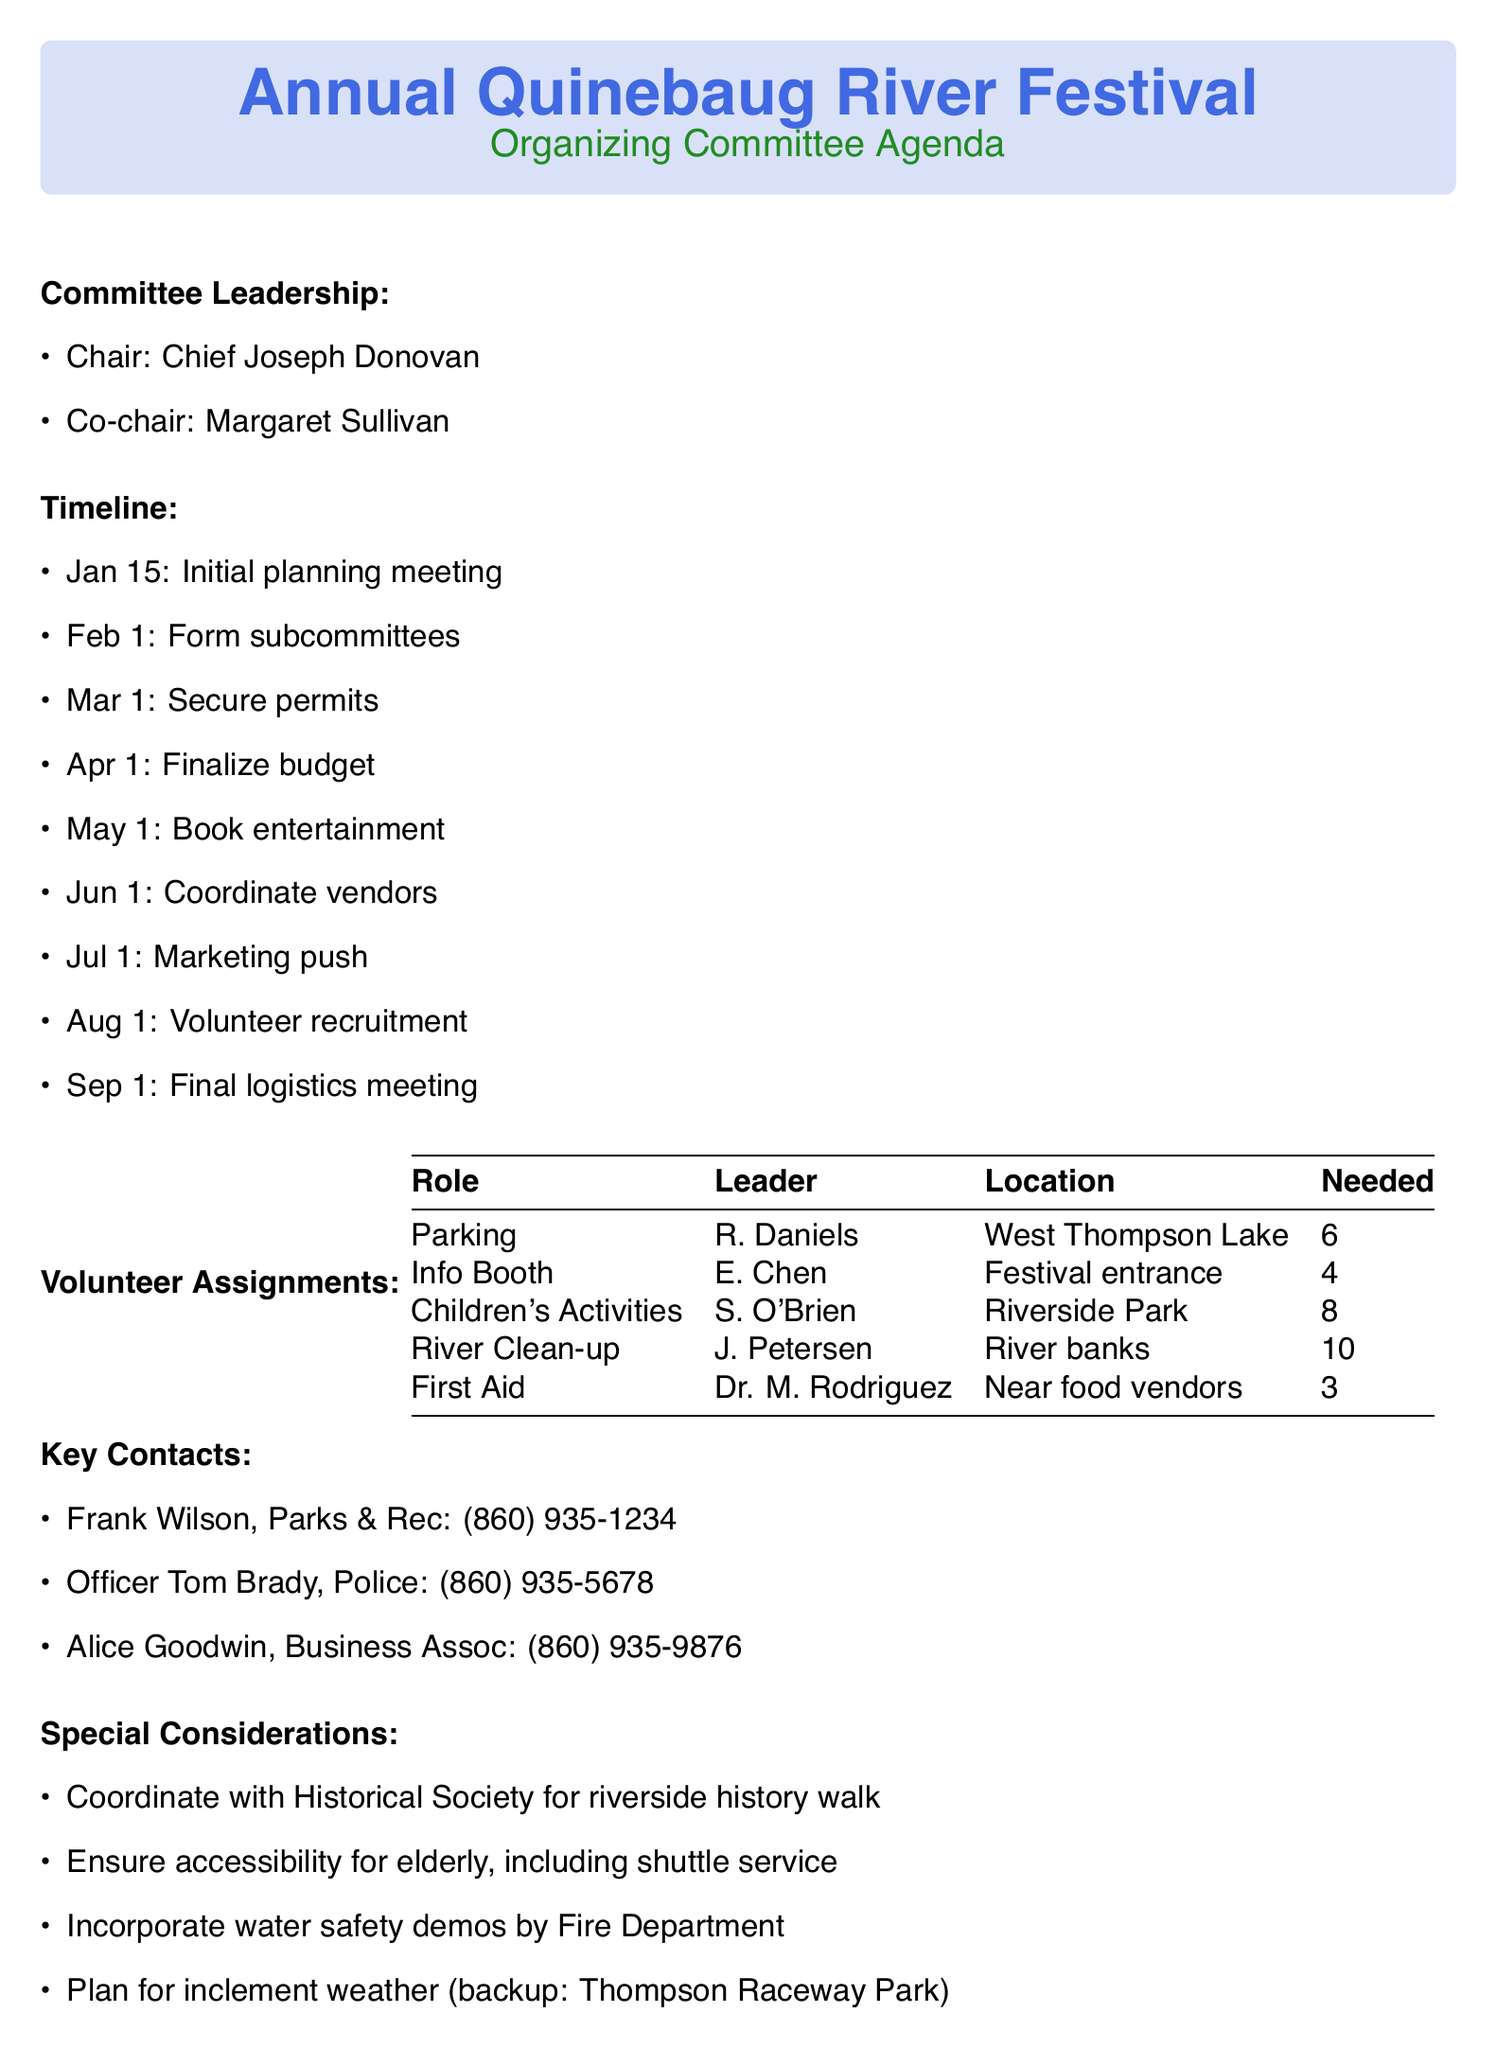What is the festival name? The festival name is explicitly stated in the document's header.
Answer: Annual Quinebaug River Festival Who is the chair of the organizing committee? The chair is mentioned in the committee leadership section of the document.
Answer: Chief Joseph Donovan When is the initial planning meeting scheduled? The date for the initial planning meeting is specified in the timeline section.
Answer: January 15 How many volunteers are needed for the children's activities? The number of volunteers required for this role is found in the volunteer assignments section.
Answer: 8 What is the location for the information booth? The location of the information booth is listed under the volunteer assignments section.
Answer: Festival entrance Which organization should be coordinated with for the riverside history walk? The coordinating organization for this activity is found under the special considerations section.
Answer: Quinebaug Historical Society How many parking attendants are required? The needed number of parking attendants is detailed in the volunteer assignments.
Answer: 6 Who leads the River clean-up crew? The leader for this volunteer assignment is mentioned in the volunteer assignments section.
Answer: John Petersen What date is the volunteer recruitment task scheduled for? The specific date for volunteer recruitment is provided in the timeline section of the document.
Answer: August 1 